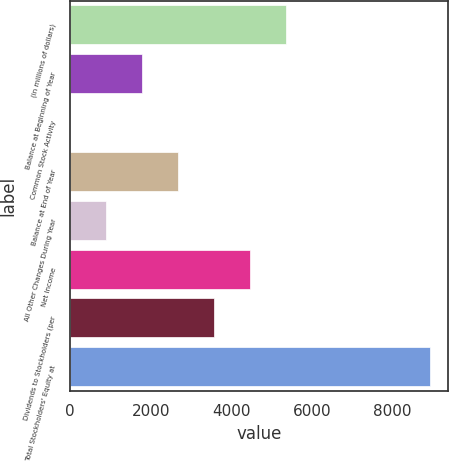Convert chart. <chart><loc_0><loc_0><loc_500><loc_500><bar_chart><fcel>(in millions of dollars)<fcel>Balance at Beginning of Year<fcel>Common Stock Activity<fcel>Balance at End of Year<fcel>All Other Changes During Year<fcel>Net Income<fcel>Dividends to Stockholders (per<fcel>Total Stockholders' Equity at<nl><fcel>5366.68<fcel>1788.96<fcel>0.1<fcel>2683.39<fcel>894.53<fcel>4472.25<fcel>3577.82<fcel>8944.4<nl></chart> 